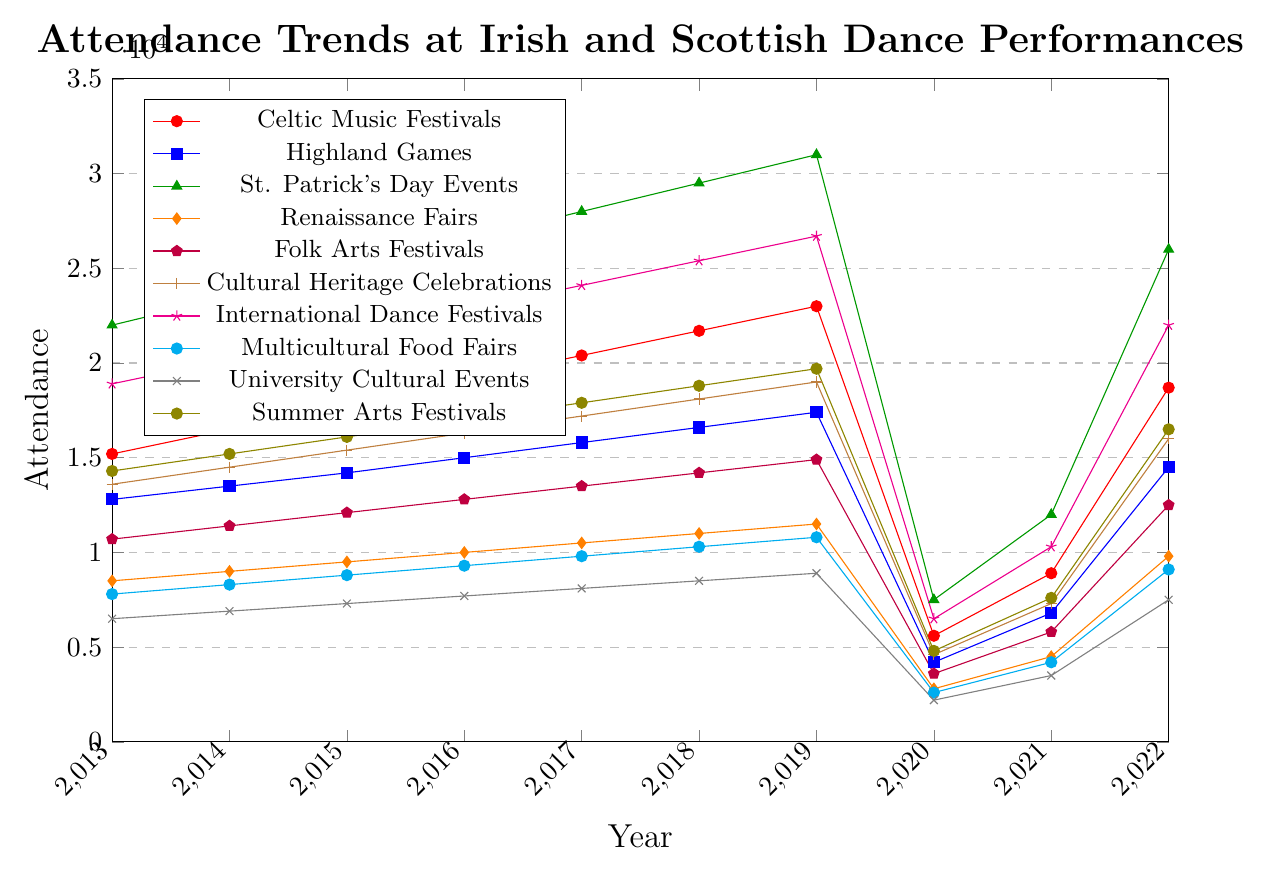Which festival had the highest attendance in 2019? Look at the 2019 data points for each festival and identify the one with the highest value. St. Patrick's Day Events had 31000 attendees.
Answer: St. Patrick's Day Events What is the trend in attendance for Multicultural Food Fairs from 2013 to 2022? Examine the line representing Multicultural Food Fairs from 2013 to 2022. The trend shows an increase from 2013 to 2019, a sharp decline in 2020, and a slow recovery in 2021 and 2022.
Answer: Increasing, sharp decline, partial recovery Which festival type experienced the most significant drop in attendance in 2020? Compare the attendance in 2019 and 2020 for each festival type and identify the largest decrease: 23000 (Celtic Music Festivals) to 5600 is a difference of 17400, the highest drop.
Answer: Celtic Music Festivals How did the attendance for Folk Arts Festivals change between 2013 and 2022? Look at the values for Folk Arts Festivals in 2013 and 2022: 10700 in 2013 and 12500 in 2022. Calculate the change: 12500 - 10700 = 1800.
Answer: Increased by 1800 Which two festivals had similar trends between 2013 and 2019? Compare the lines of different festivals. Highland Games and University Cultural Events have both steadily increasing trends without drastic changes.
Answer: Highland Games and University Cultural Events How would you describe the overall trend for the International Dance Festivals from 2013 to 2022? Inspect the International Dance Festivals line: it increases steadily from 2013 to 2019, drops in 2020, recovers partially in 2021, and rises again in 2022.
Answer: Steady increase, drop, partial recovery What is the difference in attendance between the highest and lowest attended festivals in 2022? Identify the attendance for all festivals in 2022 and find the highest (St. Patrick's Day Events, 26000) and the lowest (University Cultural Events, 7500). Calculate the difference: 26000 - 7500 = 18500.
Answer: 18500 Which festival had the least attendance in 2021? Find the lowest data point among all festivals in 2021: University Cultural Events had the lowest at 3500.
Answer: University Cultural Events In which year did Celtic Music Festivals experience the greatest increase in attendance? Calculate the year-over-year changes for Celtic Music Festivals from 2013 to 2022 and identify the year with the largest increase. The biggest increase was 2019 to 2020, 23000 - 21700 = 1300.
Answer: 2019 During which year was the attendance for each festival the most similar across all types? Find the year when the range of the highest and lowest attendance figures is the smallest. In 2021, all festivals have relatively closer attendance numbers, ranging from 3500 to 12000, making them the most similar.
Answer: 2021 